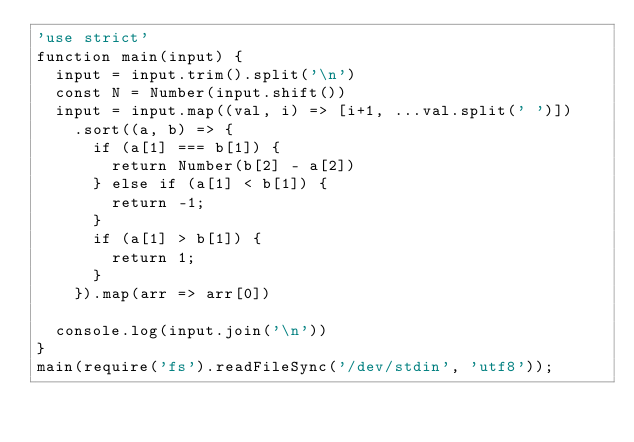<code> <loc_0><loc_0><loc_500><loc_500><_JavaScript_>'use strict'
function main(input) {
  input = input.trim().split('\n')
  const N = Number(input.shift())
  input = input.map((val, i) => [i+1, ...val.split(' ')])
    .sort((a, b) => {
      if (a[1] === b[1]) {
        return Number(b[2] - a[2])
      } else if (a[1] < b[1]) {
        return -1;
      }
      if (a[1] > b[1]) {
        return 1;
      }
    }).map(arr => arr[0])

  console.log(input.join('\n'))
}
main(require('fs').readFileSync('/dev/stdin', 'utf8'));
</code> 